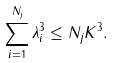<formula> <loc_0><loc_0><loc_500><loc_500>\sum _ { i = 1 } ^ { N _ { j } } \lambda _ { i } ^ { 3 } \leq N _ { j } K ^ { 3 } .</formula> 